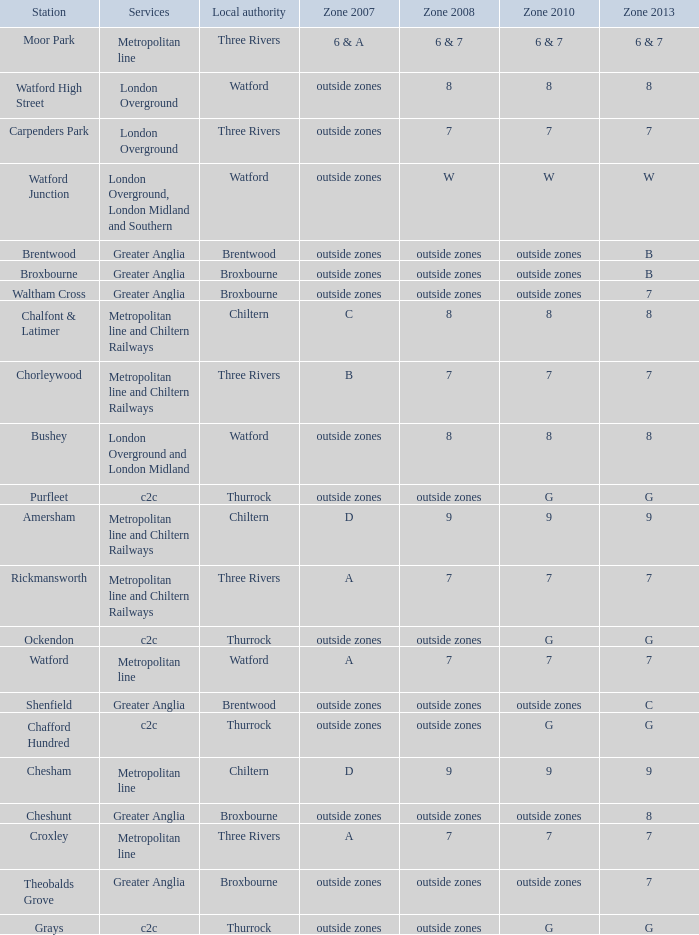Which Zone 2008 has Services of greater anglia, and a Station of cheshunt? Outside zones. 